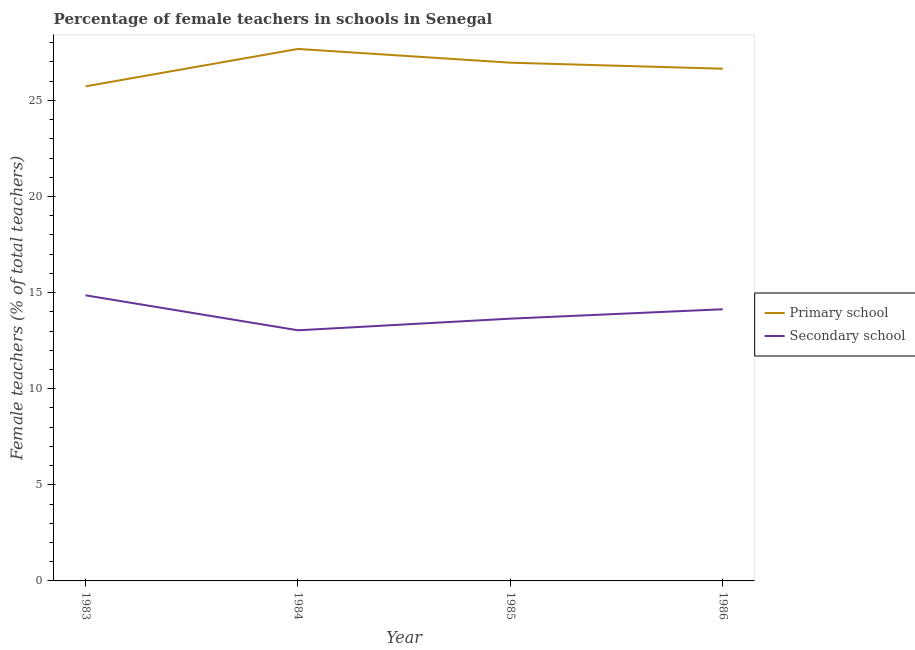Does the line corresponding to percentage of female teachers in primary schools intersect with the line corresponding to percentage of female teachers in secondary schools?
Offer a very short reply. No. Is the number of lines equal to the number of legend labels?
Provide a short and direct response. Yes. What is the percentage of female teachers in secondary schools in 1983?
Make the answer very short. 14.86. Across all years, what is the maximum percentage of female teachers in primary schools?
Keep it short and to the point. 27.68. Across all years, what is the minimum percentage of female teachers in primary schools?
Provide a short and direct response. 25.73. In which year was the percentage of female teachers in secondary schools maximum?
Your answer should be compact. 1983. In which year was the percentage of female teachers in secondary schools minimum?
Offer a terse response. 1984. What is the total percentage of female teachers in primary schools in the graph?
Provide a short and direct response. 107.03. What is the difference between the percentage of female teachers in secondary schools in 1983 and that in 1985?
Offer a very short reply. 1.21. What is the difference between the percentage of female teachers in primary schools in 1985 and the percentage of female teachers in secondary schools in 1983?
Ensure brevity in your answer.  12.1. What is the average percentage of female teachers in primary schools per year?
Provide a short and direct response. 26.76. In the year 1984, what is the difference between the percentage of female teachers in primary schools and percentage of female teachers in secondary schools?
Your answer should be compact. 14.64. What is the ratio of the percentage of female teachers in secondary schools in 1985 to that in 1986?
Your answer should be very brief. 0.97. Is the percentage of female teachers in primary schools in 1983 less than that in 1985?
Ensure brevity in your answer.  Yes. What is the difference between the highest and the second highest percentage of female teachers in secondary schools?
Your answer should be compact. 0.73. What is the difference between the highest and the lowest percentage of female teachers in primary schools?
Your answer should be compact. 1.95. In how many years, is the percentage of female teachers in secondary schools greater than the average percentage of female teachers in secondary schools taken over all years?
Give a very brief answer. 2. Does the percentage of female teachers in secondary schools monotonically increase over the years?
Your response must be concise. No. How many lines are there?
Make the answer very short. 2. How many years are there in the graph?
Provide a succinct answer. 4. What is the difference between two consecutive major ticks on the Y-axis?
Provide a short and direct response. 5. Does the graph contain any zero values?
Make the answer very short. No. Does the graph contain grids?
Ensure brevity in your answer.  No. Where does the legend appear in the graph?
Make the answer very short. Center right. How many legend labels are there?
Ensure brevity in your answer.  2. What is the title of the graph?
Keep it short and to the point. Percentage of female teachers in schools in Senegal. What is the label or title of the X-axis?
Give a very brief answer. Year. What is the label or title of the Y-axis?
Your response must be concise. Female teachers (% of total teachers). What is the Female teachers (% of total teachers) of Primary school in 1983?
Give a very brief answer. 25.73. What is the Female teachers (% of total teachers) of Secondary school in 1983?
Provide a succinct answer. 14.86. What is the Female teachers (% of total teachers) of Primary school in 1984?
Give a very brief answer. 27.68. What is the Female teachers (% of total teachers) of Secondary school in 1984?
Make the answer very short. 13.04. What is the Female teachers (% of total teachers) of Primary school in 1985?
Provide a short and direct response. 26.96. What is the Female teachers (% of total teachers) of Secondary school in 1985?
Offer a terse response. 13.65. What is the Female teachers (% of total teachers) of Primary school in 1986?
Make the answer very short. 26.65. What is the Female teachers (% of total teachers) of Secondary school in 1986?
Your response must be concise. 14.14. Across all years, what is the maximum Female teachers (% of total teachers) of Primary school?
Your response must be concise. 27.68. Across all years, what is the maximum Female teachers (% of total teachers) in Secondary school?
Make the answer very short. 14.86. Across all years, what is the minimum Female teachers (% of total teachers) in Primary school?
Your answer should be compact. 25.73. Across all years, what is the minimum Female teachers (% of total teachers) of Secondary school?
Ensure brevity in your answer.  13.04. What is the total Female teachers (% of total teachers) in Primary school in the graph?
Provide a short and direct response. 107.03. What is the total Female teachers (% of total teachers) of Secondary school in the graph?
Your response must be concise. 55.68. What is the difference between the Female teachers (% of total teachers) in Primary school in 1983 and that in 1984?
Offer a very short reply. -1.95. What is the difference between the Female teachers (% of total teachers) of Secondary school in 1983 and that in 1984?
Ensure brevity in your answer.  1.82. What is the difference between the Female teachers (% of total teachers) of Primary school in 1983 and that in 1985?
Give a very brief answer. -1.23. What is the difference between the Female teachers (% of total teachers) in Secondary school in 1983 and that in 1985?
Your response must be concise. 1.21. What is the difference between the Female teachers (% of total teachers) in Primary school in 1983 and that in 1986?
Provide a short and direct response. -0.92. What is the difference between the Female teachers (% of total teachers) of Secondary school in 1983 and that in 1986?
Your answer should be very brief. 0.73. What is the difference between the Female teachers (% of total teachers) of Primary school in 1984 and that in 1985?
Your answer should be compact. 0.72. What is the difference between the Female teachers (% of total teachers) of Secondary school in 1984 and that in 1985?
Ensure brevity in your answer.  -0.61. What is the difference between the Female teachers (% of total teachers) in Primary school in 1984 and that in 1986?
Keep it short and to the point. 1.03. What is the difference between the Female teachers (% of total teachers) in Secondary school in 1984 and that in 1986?
Your answer should be compact. -1.09. What is the difference between the Female teachers (% of total teachers) in Primary school in 1985 and that in 1986?
Ensure brevity in your answer.  0.31. What is the difference between the Female teachers (% of total teachers) of Secondary school in 1985 and that in 1986?
Your answer should be compact. -0.49. What is the difference between the Female teachers (% of total teachers) of Primary school in 1983 and the Female teachers (% of total teachers) of Secondary school in 1984?
Your answer should be compact. 12.69. What is the difference between the Female teachers (% of total teachers) in Primary school in 1983 and the Female teachers (% of total teachers) in Secondary school in 1985?
Provide a succinct answer. 12.09. What is the difference between the Female teachers (% of total teachers) in Primary school in 1983 and the Female teachers (% of total teachers) in Secondary school in 1986?
Offer a very short reply. 11.6. What is the difference between the Female teachers (% of total teachers) in Primary school in 1984 and the Female teachers (% of total teachers) in Secondary school in 1985?
Keep it short and to the point. 14.03. What is the difference between the Female teachers (% of total teachers) in Primary school in 1984 and the Female teachers (% of total teachers) in Secondary school in 1986?
Your answer should be compact. 13.54. What is the difference between the Female teachers (% of total teachers) in Primary school in 1985 and the Female teachers (% of total teachers) in Secondary school in 1986?
Provide a short and direct response. 12.83. What is the average Female teachers (% of total teachers) in Primary school per year?
Give a very brief answer. 26.76. What is the average Female teachers (% of total teachers) of Secondary school per year?
Make the answer very short. 13.92. In the year 1983, what is the difference between the Female teachers (% of total teachers) of Primary school and Female teachers (% of total teachers) of Secondary school?
Ensure brevity in your answer.  10.87. In the year 1984, what is the difference between the Female teachers (% of total teachers) in Primary school and Female teachers (% of total teachers) in Secondary school?
Your answer should be very brief. 14.64. In the year 1985, what is the difference between the Female teachers (% of total teachers) in Primary school and Female teachers (% of total teachers) in Secondary school?
Your answer should be very brief. 13.32. In the year 1986, what is the difference between the Female teachers (% of total teachers) in Primary school and Female teachers (% of total teachers) in Secondary school?
Your answer should be compact. 12.52. What is the ratio of the Female teachers (% of total teachers) of Primary school in 1983 to that in 1984?
Make the answer very short. 0.93. What is the ratio of the Female teachers (% of total teachers) of Secondary school in 1983 to that in 1984?
Ensure brevity in your answer.  1.14. What is the ratio of the Female teachers (% of total teachers) of Primary school in 1983 to that in 1985?
Provide a succinct answer. 0.95. What is the ratio of the Female teachers (% of total teachers) in Secondary school in 1983 to that in 1985?
Your answer should be compact. 1.09. What is the ratio of the Female teachers (% of total teachers) of Primary school in 1983 to that in 1986?
Your answer should be very brief. 0.97. What is the ratio of the Female teachers (% of total teachers) of Secondary school in 1983 to that in 1986?
Provide a short and direct response. 1.05. What is the ratio of the Female teachers (% of total teachers) in Primary school in 1984 to that in 1985?
Your answer should be compact. 1.03. What is the ratio of the Female teachers (% of total teachers) in Secondary school in 1984 to that in 1985?
Your answer should be compact. 0.96. What is the ratio of the Female teachers (% of total teachers) in Primary school in 1984 to that in 1986?
Make the answer very short. 1.04. What is the ratio of the Female teachers (% of total teachers) of Secondary school in 1984 to that in 1986?
Your answer should be very brief. 0.92. What is the ratio of the Female teachers (% of total teachers) in Primary school in 1985 to that in 1986?
Provide a short and direct response. 1.01. What is the ratio of the Female teachers (% of total teachers) of Secondary school in 1985 to that in 1986?
Your response must be concise. 0.97. What is the difference between the highest and the second highest Female teachers (% of total teachers) in Primary school?
Provide a succinct answer. 0.72. What is the difference between the highest and the second highest Female teachers (% of total teachers) in Secondary school?
Your answer should be very brief. 0.73. What is the difference between the highest and the lowest Female teachers (% of total teachers) in Primary school?
Provide a short and direct response. 1.95. What is the difference between the highest and the lowest Female teachers (% of total teachers) of Secondary school?
Provide a short and direct response. 1.82. 